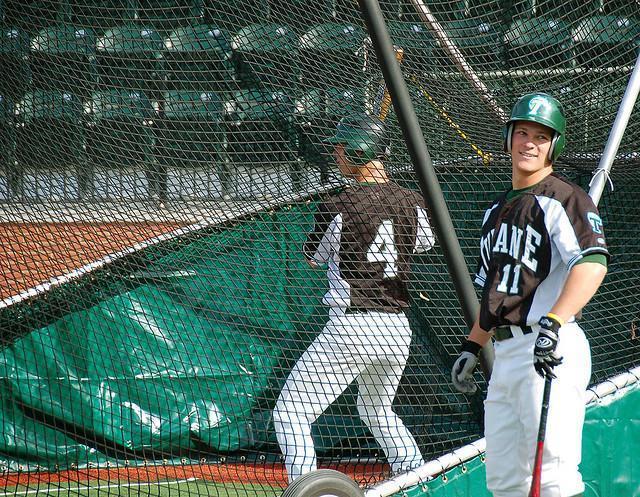How many people can be seen?
Give a very brief answer. 2. How many chairs can be seen?
Give a very brief answer. 6. 